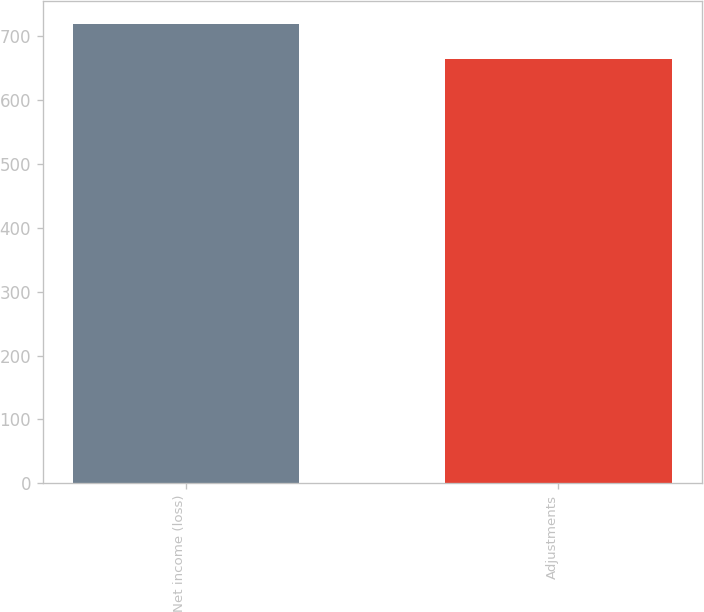<chart> <loc_0><loc_0><loc_500><loc_500><bar_chart><fcel>Net income (loss)<fcel>Adjustments<nl><fcel>719<fcel>664<nl></chart> 